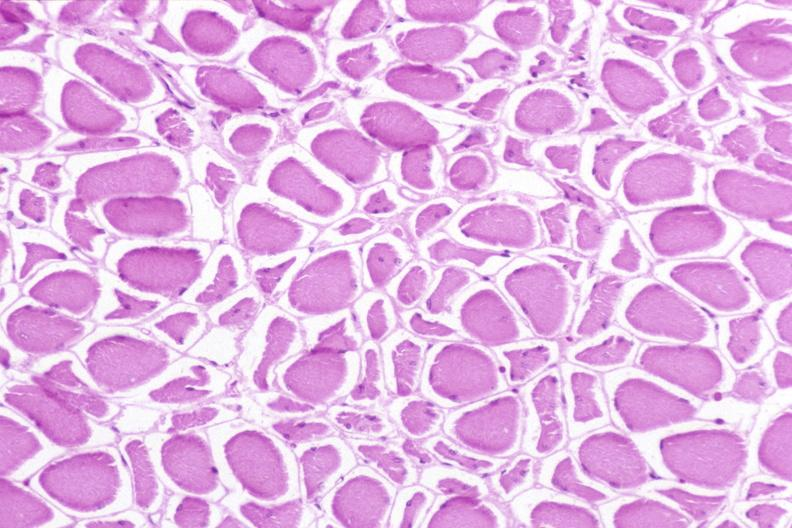why does this image show skeletal muscle, atrophy?
Answer the question using a single word or phrase. Due to immobilization cast 